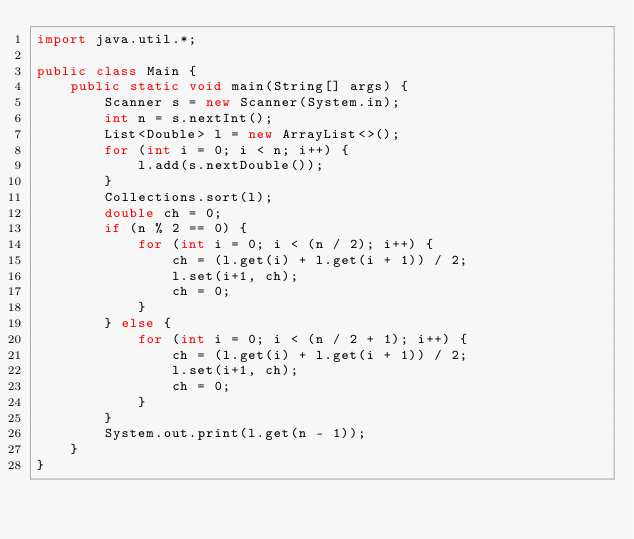<code> <loc_0><loc_0><loc_500><loc_500><_Java_>import java.util.*;

public class Main {
    public static void main(String[] args) {
        Scanner s = new Scanner(System.in);
        int n = s.nextInt();
        List<Double> l = new ArrayList<>();
        for (int i = 0; i < n; i++) {
            l.add(s.nextDouble());
        }
        Collections.sort(l);
        double ch = 0;
        if (n % 2 == 0) {
            for (int i = 0; i < (n / 2); i++) {
                ch = (l.get(i) + l.get(i + 1)) / 2;
                l.set(i+1, ch);
                ch = 0;
            }
        } else {
            for (int i = 0; i < (n / 2 + 1); i++) {
                ch = (l.get(i) + l.get(i + 1)) / 2;
                l.set(i+1, ch);
                ch = 0;
            }
        }
        System.out.print(l.get(n - 1));
    }
}</code> 